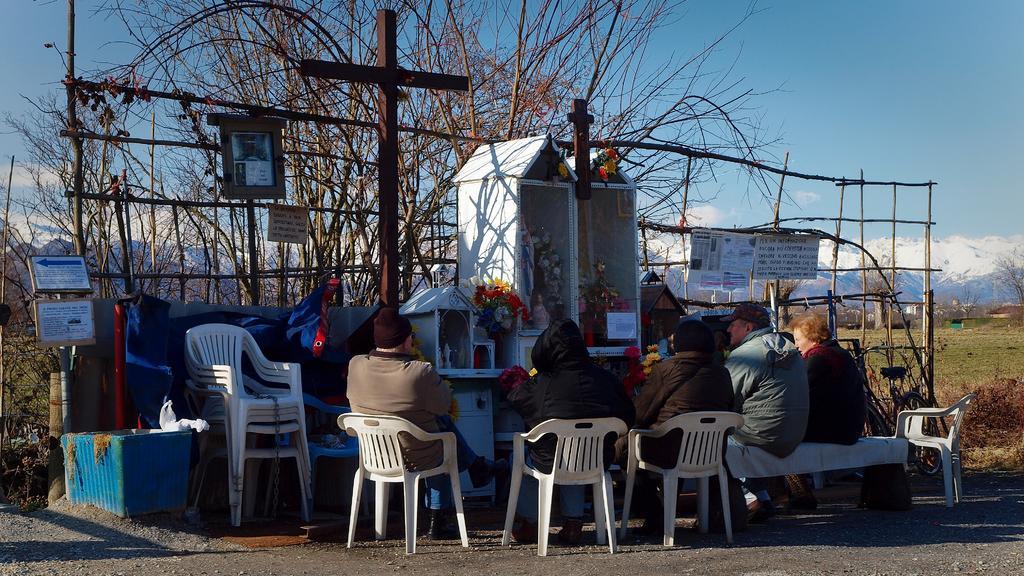How would you summarize this image in a sentence or two? Here we can see some persons were sitting on the chair and they were facing that side. And we can see the cross and coming to the background we can see the sky and some trees with white mountain and some sign boards. 